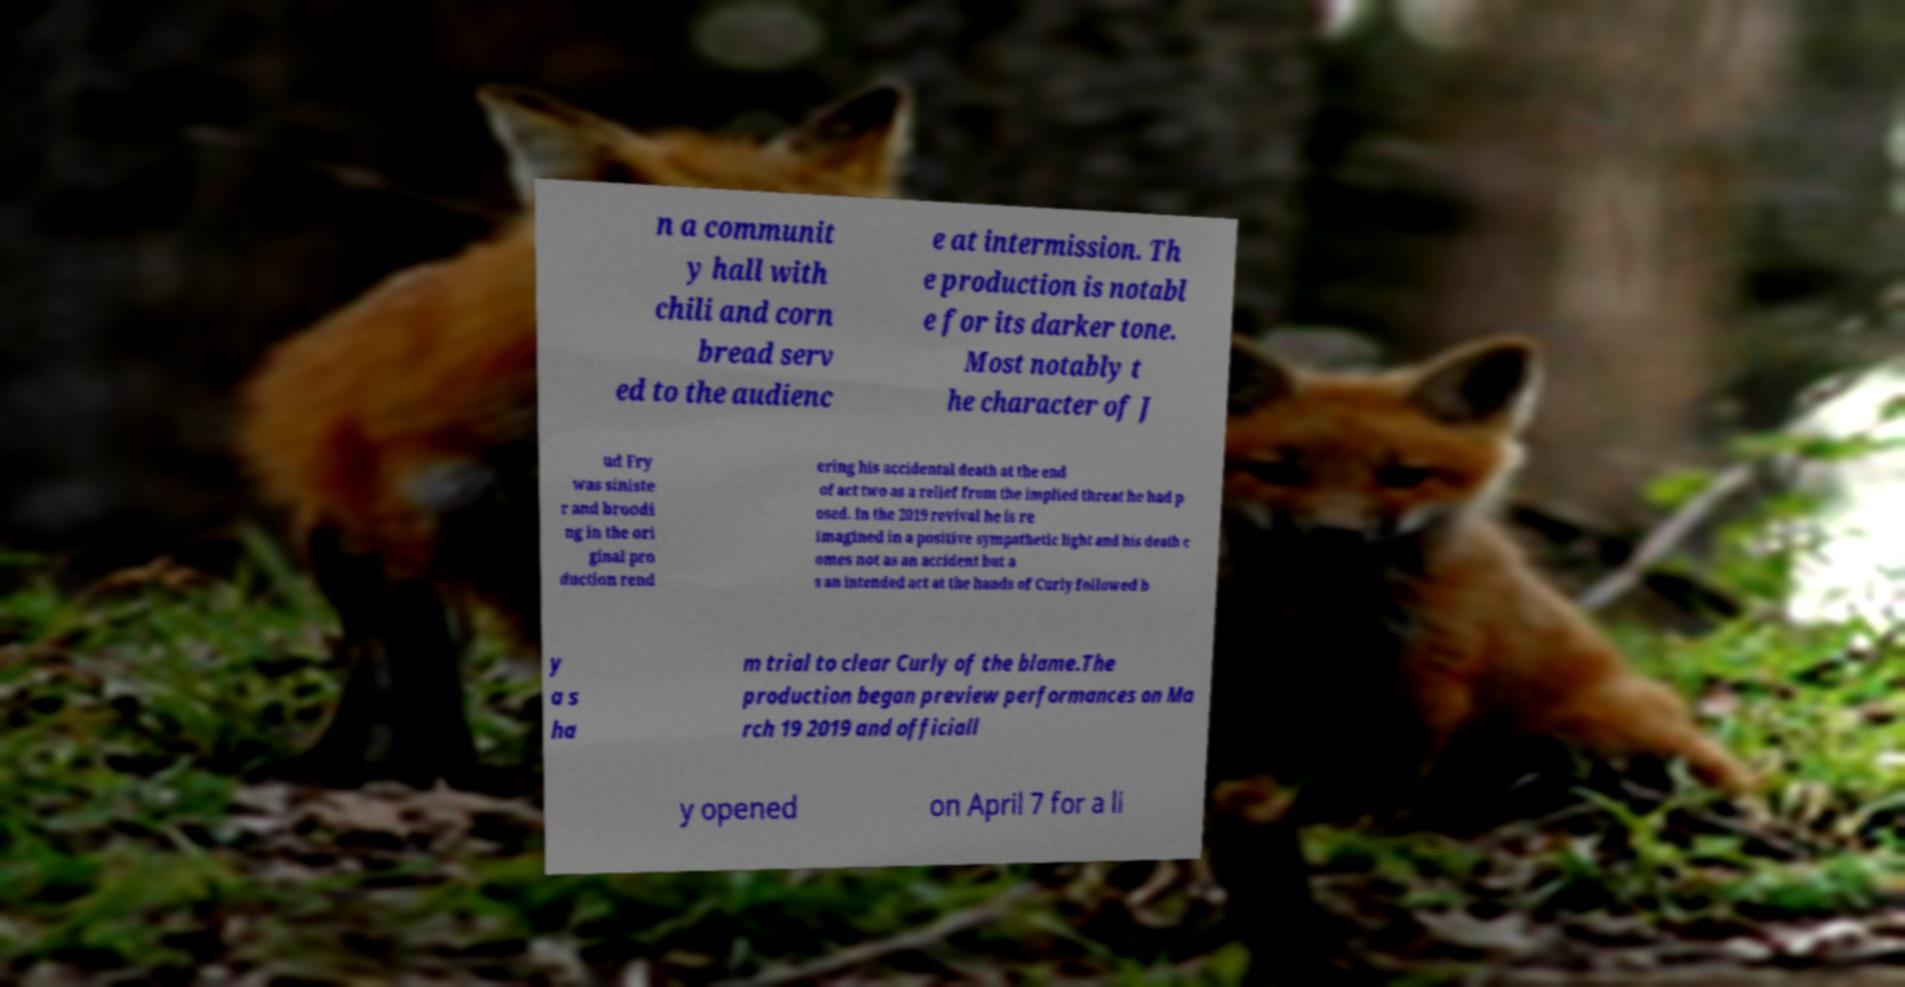Can you accurately transcribe the text from the provided image for me? n a communit y hall with chili and corn bread serv ed to the audienc e at intermission. Th e production is notabl e for its darker tone. Most notably t he character of J ud Fry was siniste r and broodi ng in the ori ginal pro duction rend ering his accidental death at the end of act two as a relief from the implied threat he had p osed. In the 2019 revival he is re imagined in a positive sympathetic light and his death c omes not as an accident but a s an intended act at the hands of Curly followed b y a s ha m trial to clear Curly of the blame.The production began preview performances on Ma rch 19 2019 and officiall y opened on April 7 for a li 